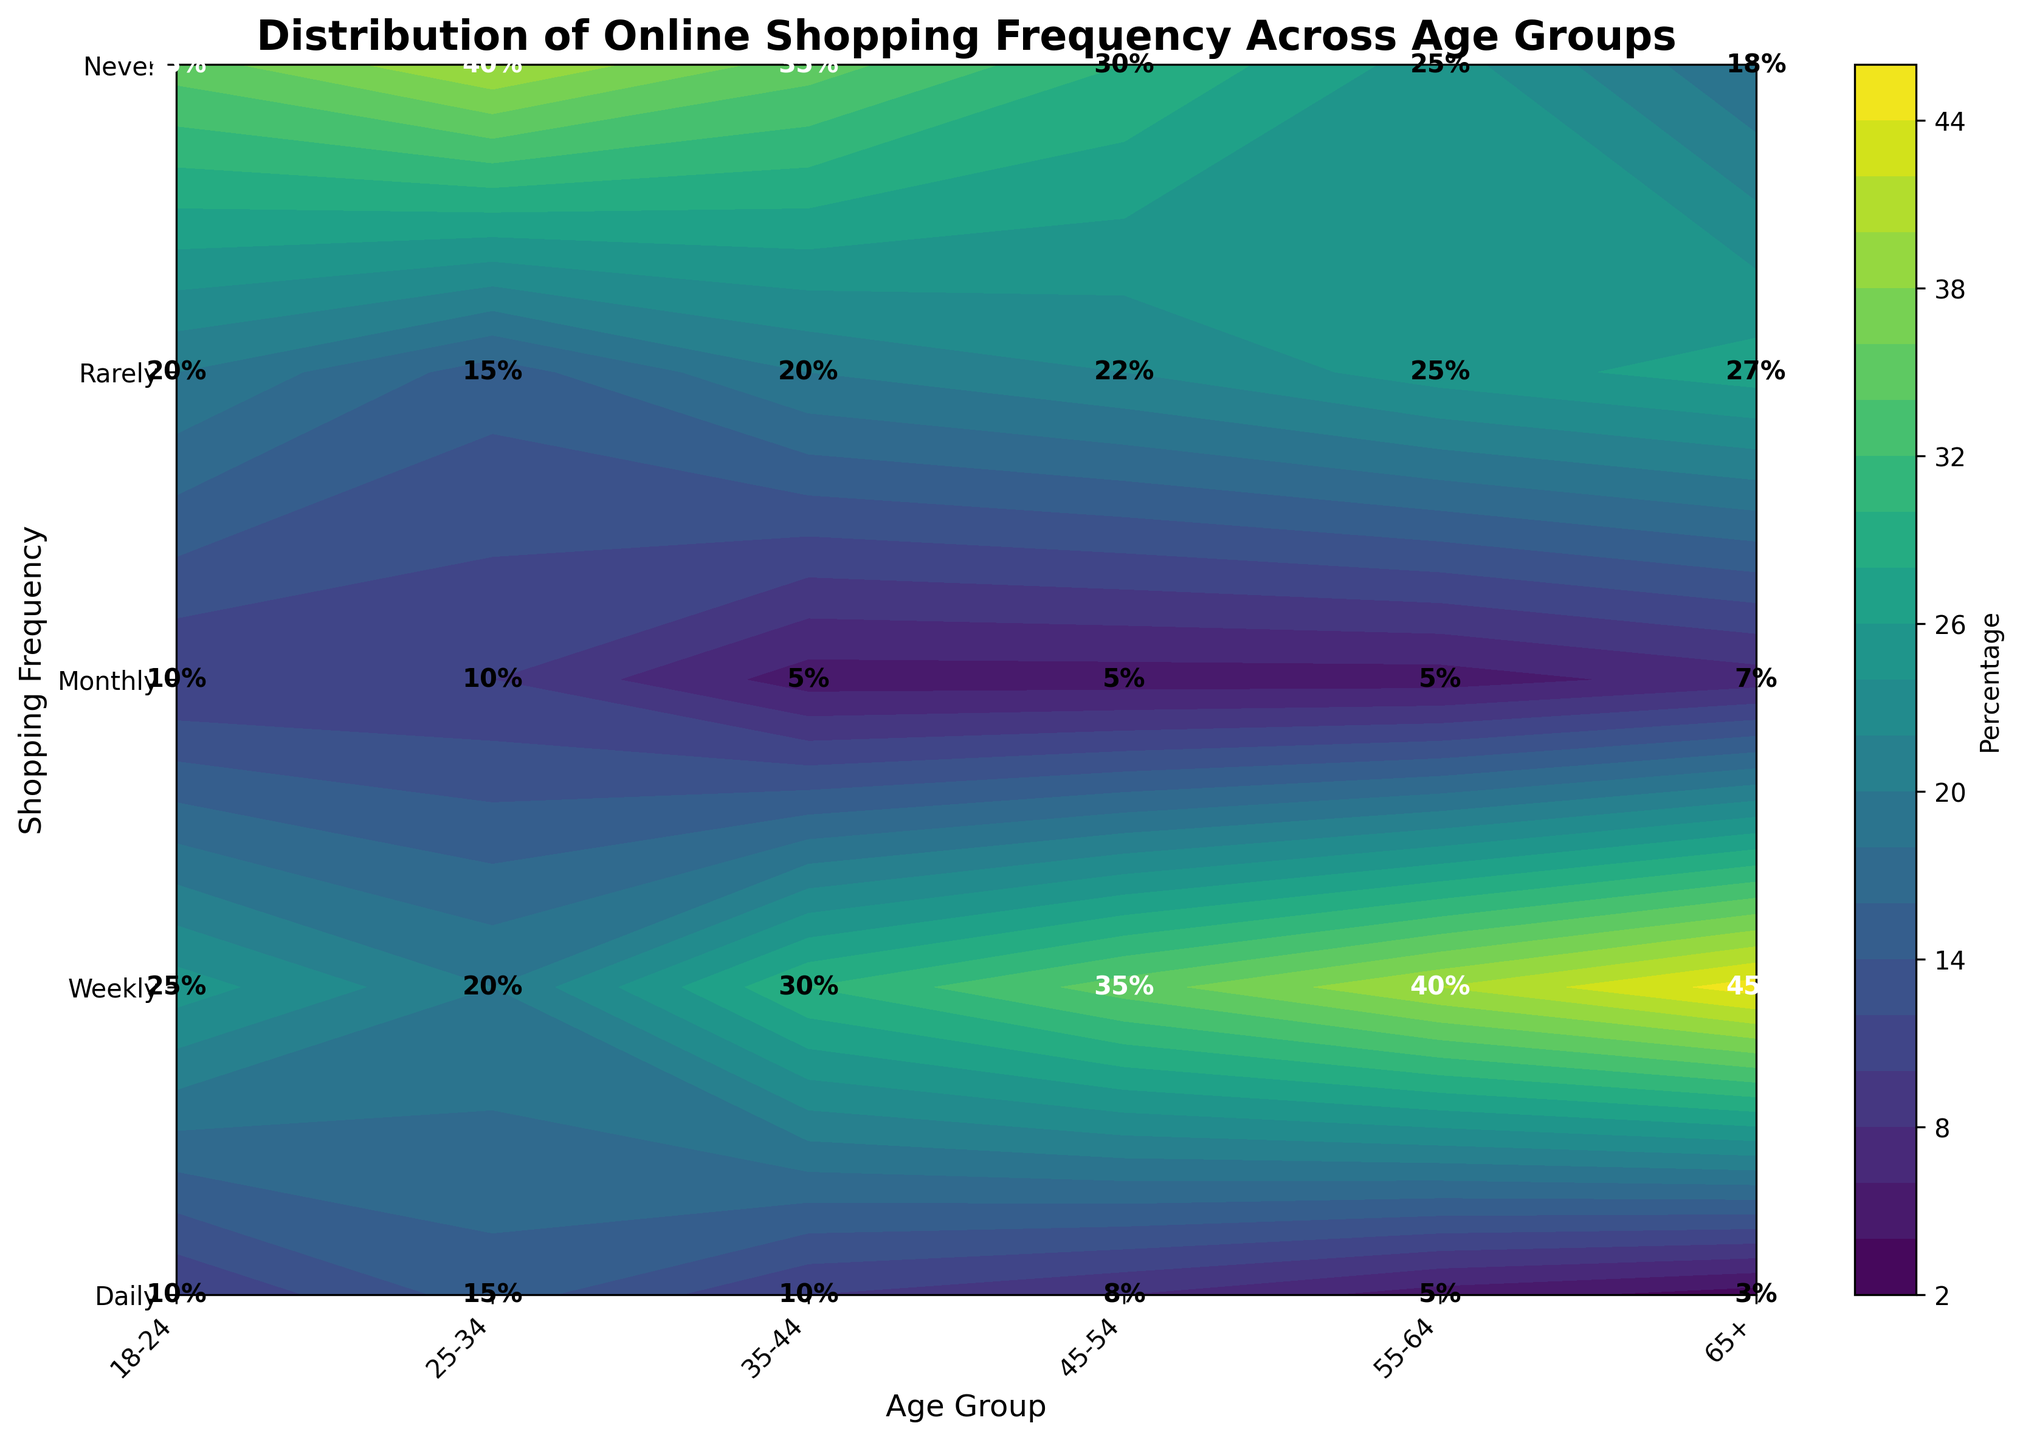What is the title of the plot? The title is displayed prominently at the top of the figure.
Answer: Distribution of Online Shopping Frequency Across Age Groups What are the labels of the x-axis and y-axis? The x-axis label is found near the horizontal axis at the bottom of the plot, and the y-axis label is found near the vertical axis on the left side of the plot.
Answer: Age Group (x-axis), Shopping Frequency (y-axis) Which age group has the highest percentage for the 'Weekly' shopping frequency? Locate the 'Weekly' y-axis label, trace horizontally to find the maximum percentage value, and then trace vertically to the corresponding age group.
Answer: 25-34 How many different shopping frequencies are displayed in the plot? Count the number of distinct y-axis labels representing shopping frequencies.
Answer: 5 For the age group 45-54, what is the percentage for 'Monthly' online shopping? Locate the x-axis label '45-54', then trace vertically to the 'Monthly' y-axis label and check the percentage labeled inside the plot.
Answer: 35% Which age group has the lowest percentage for the 'Daily' shopping frequency? Find the lowest value among the percentages within the 'Daily' row and trace back to the corresponding age group.
Answer: 65+ What is the average percentage of 'Never' shopping frequency across all age groups? Sum the percentages for the 'Never' row (10% + 10% + 5% + 5% + 5% + 7%) and divide by the number of age groups (6).
Answer: 7% Where is the contour density highest for 'Daily' shopping, and which age group corresponds to it? Look for the darkest shaded area within the 'Daily' row and identify the corresponding age group on the x-axis.
Answer: 25-34 Compare the percentages for 'Monthly' shopping frequency between age groups 18-24 and 55-64. Which is higher? Locate the percentages for 'Monthly' in these two age groups: 18-24 (25%) and 55-64 (40%). Compare them to identify the higher percentage.
Answer: 55-64 Is there an age group where 'Rarely' online shopping frequency exceeds 25%? If so, which one? Identify the 'Rarely' row and scan across for values greater than 25%. Look up the corresponding age group.
Answer: 65+ 